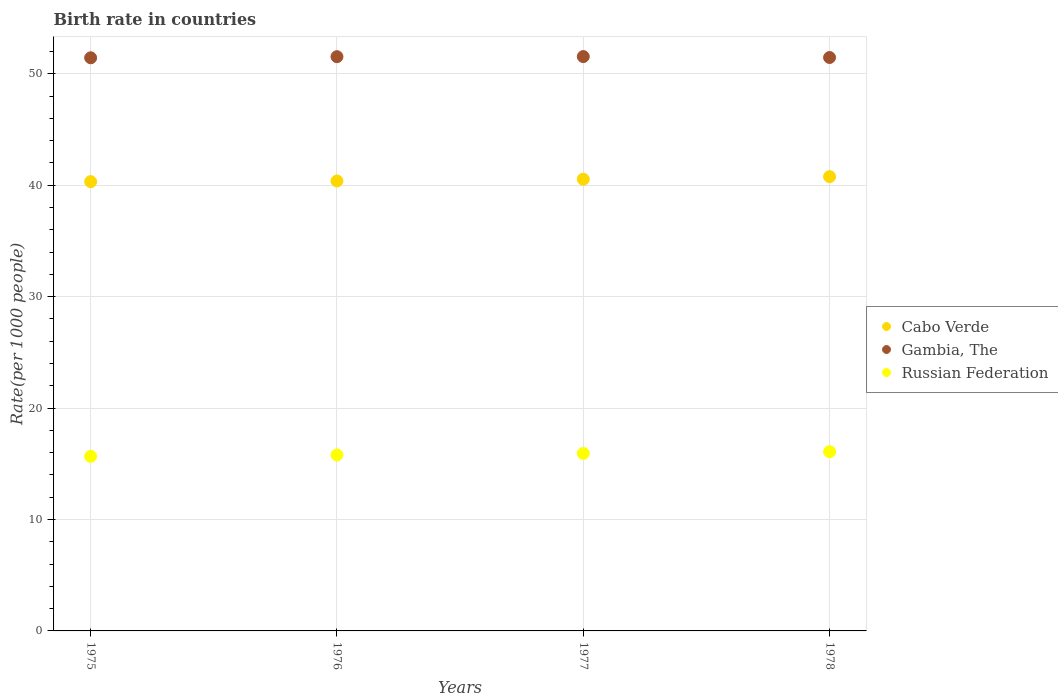How many different coloured dotlines are there?
Offer a terse response. 3. Is the number of dotlines equal to the number of legend labels?
Your answer should be very brief. Yes. What is the birth rate in Gambia, The in 1978?
Offer a very short reply. 51.45. Across all years, what is the maximum birth rate in Cabo Verde?
Keep it short and to the point. 40.76. Across all years, what is the minimum birth rate in Russian Federation?
Provide a short and direct response. 15.66. In which year was the birth rate in Cabo Verde minimum?
Offer a terse response. 1975. What is the total birth rate in Gambia, The in the graph?
Provide a short and direct response. 205.95. What is the difference between the birth rate in Cabo Verde in 1975 and that in 1976?
Provide a succinct answer. -0.06. What is the difference between the birth rate in Gambia, The in 1978 and the birth rate in Cabo Verde in 1977?
Offer a very short reply. 10.92. What is the average birth rate in Gambia, The per year?
Your answer should be very brief. 51.49. In the year 1977, what is the difference between the birth rate in Cabo Verde and birth rate in Gambia, The?
Provide a succinct answer. -11.01. What is the ratio of the birth rate in Gambia, The in 1975 to that in 1978?
Keep it short and to the point. 1. What is the difference between the highest and the second highest birth rate in Cabo Verde?
Offer a very short reply. 0.23. What is the difference between the highest and the lowest birth rate in Gambia, The?
Your response must be concise. 0.11. Is the sum of the birth rate in Gambia, The in 1975 and 1978 greater than the maximum birth rate in Cabo Verde across all years?
Make the answer very short. Yes. Is it the case that in every year, the sum of the birth rate in Russian Federation and birth rate in Cabo Verde  is greater than the birth rate in Gambia, The?
Make the answer very short. Yes. Does the birth rate in Gambia, The monotonically increase over the years?
Make the answer very short. No. How many years are there in the graph?
Your answer should be compact. 4. What is the difference between two consecutive major ticks on the Y-axis?
Your answer should be compact. 10. Are the values on the major ticks of Y-axis written in scientific E-notation?
Ensure brevity in your answer.  No. Does the graph contain any zero values?
Your response must be concise. No. How are the legend labels stacked?
Give a very brief answer. Vertical. What is the title of the graph?
Provide a short and direct response. Birth rate in countries. What is the label or title of the X-axis?
Your answer should be compact. Years. What is the label or title of the Y-axis?
Offer a terse response. Rate(per 1000 people). What is the Rate(per 1000 people) in Cabo Verde in 1975?
Provide a short and direct response. 40.32. What is the Rate(per 1000 people) in Gambia, The in 1975?
Your answer should be compact. 51.43. What is the Rate(per 1000 people) in Russian Federation in 1975?
Your answer should be compact. 15.66. What is the Rate(per 1000 people) of Cabo Verde in 1976?
Your response must be concise. 40.38. What is the Rate(per 1000 people) in Gambia, The in 1976?
Your response must be concise. 51.53. What is the Rate(per 1000 people) of Russian Federation in 1976?
Make the answer very short. 15.79. What is the Rate(per 1000 people) in Cabo Verde in 1977?
Keep it short and to the point. 40.53. What is the Rate(per 1000 people) in Gambia, The in 1977?
Your answer should be very brief. 51.54. What is the Rate(per 1000 people) in Russian Federation in 1977?
Your answer should be compact. 15.92. What is the Rate(per 1000 people) of Cabo Verde in 1978?
Offer a very short reply. 40.76. What is the Rate(per 1000 people) of Gambia, The in 1978?
Offer a terse response. 51.45. What is the Rate(per 1000 people) of Russian Federation in 1978?
Give a very brief answer. 16.08. Across all years, what is the maximum Rate(per 1000 people) of Cabo Verde?
Make the answer very short. 40.76. Across all years, what is the maximum Rate(per 1000 people) of Gambia, The?
Keep it short and to the point. 51.54. Across all years, what is the maximum Rate(per 1000 people) in Russian Federation?
Keep it short and to the point. 16.08. Across all years, what is the minimum Rate(per 1000 people) in Cabo Verde?
Offer a terse response. 40.32. Across all years, what is the minimum Rate(per 1000 people) of Gambia, The?
Offer a terse response. 51.43. Across all years, what is the minimum Rate(per 1000 people) of Russian Federation?
Give a very brief answer. 15.66. What is the total Rate(per 1000 people) of Cabo Verde in the graph?
Ensure brevity in your answer.  161.99. What is the total Rate(per 1000 people) of Gambia, The in the graph?
Ensure brevity in your answer.  205.95. What is the total Rate(per 1000 people) of Russian Federation in the graph?
Provide a short and direct response. 63.45. What is the difference between the Rate(per 1000 people) in Cabo Verde in 1975 and that in 1976?
Ensure brevity in your answer.  -0.06. What is the difference between the Rate(per 1000 people) in Russian Federation in 1975 and that in 1976?
Provide a succinct answer. -0.13. What is the difference between the Rate(per 1000 people) in Cabo Verde in 1975 and that in 1977?
Make the answer very short. -0.22. What is the difference between the Rate(per 1000 people) in Gambia, The in 1975 and that in 1977?
Offer a very short reply. -0.11. What is the difference between the Rate(per 1000 people) of Russian Federation in 1975 and that in 1977?
Offer a terse response. -0.26. What is the difference between the Rate(per 1000 people) in Cabo Verde in 1975 and that in 1978?
Your answer should be compact. -0.45. What is the difference between the Rate(per 1000 people) in Gambia, The in 1975 and that in 1978?
Provide a succinct answer. -0.03. What is the difference between the Rate(per 1000 people) of Russian Federation in 1975 and that in 1978?
Make the answer very short. -0.42. What is the difference between the Rate(per 1000 people) of Cabo Verde in 1976 and that in 1977?
Give a very brief answer. -0.16. What is the difference between the Rate(per 1000 people) of Gambia, The in 1976 and that in 1977?
Provide a short and direct response. -0.01. What is the difference between the Rate(per 1000 people) in Russian Federation in 1976 and that in 1977?
Keep it short and to the point. -0.13. What is the difference between the Rate(per 1000 people) in Cabo Verde in 1976 and that in 1978?
Your response must be concise. -0.39. What is the difference between the Rate(per 1000 people) of Gambia, The in 1976 and that in 1978?
Give a very brief answer. 0.07. What is the difference between the Rate(per 1000 people) in Russian Federation in 1976 and that in 1978?
Your response must be concise. -0.29. What is the difference between the Rate(per 1000 people) in Cabo Verde in 1977 and that in 1978?
Ensure brevity in your answer.  -0.23. What is the difference between the Rate(per 1000 people) in Gambia, The in 1977 and that in 1978?
Keep it short and to the point. 0.08. What is the difference between the Rate(per 1000 people) of Russian Federation in 1977 and that in 1978?
Your response must be concise. -0.16. What is the difference between the Rate(per 1000 people) in Cabo Verde in 1975 and the Rate(per 1000 people) in Gambia, The in 1976?
Your response must be concise. -11.21. What is the difference between the Rate(per 1000 people) in Cabo Verde in 1975 and the Rate(per 1000 people) in Russian Federation in 1976?
Your response must be concise. 24.53. What is the difference between the Rate(per 1000 people) in Gambia, The in 1975 and the Rate(per 1000 people) in Russian Federation in 1976?
Your answer should be very brief. 35.64. What is the difference between the Rate(per 1000 people) in Cabo Verde in 1975 and the Rate(per 1000 people) in Gambia, The in 1977?
Your answer should be very brief. -11.22. What is the difference between the Rate(per 1000 people) of Cabo Verde in 1975 and the Rate(per 1000 people) of Russian Federation in 1977?
Provide a short and direct response. 24.39. What is the difference between the Rate(per 1000 people) of Gambia, The in 1975 and the Rate(per 1000 people) of Russian Federation in 1977?
Your answer should be compact. 35.51. What is the difference between the Rate(per 1000 people) in Cabo Verde in 1975 and the Rate(per 1000 people) in Gambia, The in 1978?
Provide a succinct answer. -11.14. What is the difference between the Rate(per 1000 people) of Cabo Verde in 1975 and the Rate(per 1000 people) of Russian Federation in 1978?
Your answer should be compact. 24.24. What is the difference between the Rate(per 1000 people) of Gambia, The in 1975 and the Rate(per 1000 people) of Russian Federation in 1978?
Make the answer very short. 35.35. What is the difference between the Rate(per 1000 people) in Cabo Verde in 1976 and the Rate(per 1000 people) in Gambia, The in 1977?
Give a very brief answer. -11.16. What is the difference between the Rate(per 1000 people) in Cabo Verde in 1976 and the Rate(per 1000 people) in Russian Federation in 1977?
Give a very brief answer. 24.45. What is the difference between the Rate(per 1000 people) of Gambia, The in 1976 and the Rate(per 1000 people) of Russian Federation in 1977?
Give a very brief answer. 35.61. What is the difference between the Rate(per 1000 people) in Cabo Verde in 1976 and the Rate(per 1000 people) in Gambia, The in 1978?
Provide a short and direct response. -11.08. What is the difference between the Rate(per 1000 people) in Cabo Verde in 1976 and the Rate(per 1000 people) in Russian Federation in 1978?
Your answer should be compact. 24.3. What is the difference between the Rate(per 1000 people) in Gambia, The in 1976 and the Rate(per 1000 people) in Russian Federation in 1978?
Give a very brief answer. 35.45. What is the difference between the Rate(per 1000 people) of Cabo Verde in 1977 and the Rate(per 1000 people) of Gambia, The in 1978?
Give a very brief answer. -10.92. What is the difference between the Rate(per 1000 people) in Cabo Verde in 1977 and the Rate(per 1000 people) in Russian Federation in 1978?
Ensure brevity in your answer.  24.45. What is the difference between the Rate(per 1000 people) of Gambia, The in 1977 and the Rate(per 1000 people) of Russian Federation in 1978?
Your answer should be very brief. 35.46. What is the average Rate(per 1000 people) in Cabo Verde per year?
Your answer should be compact. 40.5. What is the average Rate(per 1000 people) of Gambia, The per year?
Offer a very short reply. 51.49. What is the average Rate(per 1000 people) of Russian Federation per year?
Your answer should be very brief. 15.86. In the year 1975, what is the difference between the Rate(per 1000 people) of Cabo Verde and Rate(per 1000 people) of Gambia, The?
Provide a short and direct response. -11.11. In the year 1975, what is the difference between the Rate(per 1000 people) in Cabo Verde and Rate(per 1000 people) in Russian Federation?
Provide a short and direct response. 24.65. In the year 1975, what is the difference between the Rate(per 1000 people) in Gambia, The and Rate(per 1000 people) in Russian Federation?
Your answer should be very brief. 35.77. In the year 1976, what is the difference between the Rate(per 1000 people) of Cabo Verde and Rate(per 1000 people) of Gambia, The?
Ensure brevity in your answer.  -11.15. In the year 1976, what is the difference between the Rate(per 1000 people) of Cabo Verde and Rate(per 1000 people) of Russian Federation?
Provide a short and direct response. 24.59. In the year 1976, what is the difference between the Rate(per 1000 people) of Gambia, The and Rate(per 1000 people) of Russian Federation?
Offer a very short reply. 35.74. In the year 1977, what is the difference between the Rate(per 1000 people) in Cabo Verde and Rate(per 1000 people) in Gambia, The?
Your answer should be very brief. -11.01. In the year 1977, what is the difference between the Rate(per 1000 people) of Cabo Verde and Rate(per 1000 people) of Russian Federation?
Your answer should be compact. 24.61. In the year 1977, what is the difference between the Rate(per 1000 people) in Gambia, The and Rate(per 1000 people) in Russian Federation?
Your answer should be very brief. 35.62. In the year 1978, what is the difference between the Rate(per 1000 people) of Cabo Verde and Rate(per 1000 people) of Gambia, The?
Offer a very short reply. -10.69. In the year 1978, what is the difference between the Rate(per 1000 people) of Cabo Verde and Rate(per 1000 people) of Russian Federation?
Your answer should be very brief. 24.68. In the year 1978, what is the difference between the Rate(per 1000 people) of Gambia, The and Rate(per 1000 people) of Russian Federation?
Make the answer very short. 35.38. What is the ratio of the Rate(per 1000 people) in Gambia, The in 1975 to that in 1976?
Your answer should be very brief. 1. What is the ratio of the Rate(per 1000 people) of Russian Federation in 1975 to that in 1976?
Make the answer very short. 0.99. What is the ratio of the Rate(per 1000 people) of Cabo Verde in 1975 to that in 1977?
Give a very brief answer. 0.99. What is the ratio of the Rate(per 1000 people) in Gambia, The in 1975 to that in 1977?
Ensure brevity in your answer.  1. What is the ratio of the Rate(per 1000 people) of Russian Federation in 1975 to that in 1977?
Provide a succinct answer. 0.98. What is the ratio of the Rate(per 1000 people) of Gambia, The in 1975 to that in 1978?
Your answer should be very brief. 1. What is the ratio of the Rate(per 1000 people) in Russian Federation in 1975 to that in 1978?
Provide a short and direct response. 0.97. What is the ratio of the Rate(per 1000 people) in Russian Federation in 1976 to that in 1977?
Offer a very short reply. 0.99. What is the ratio of the Rate(per 1000 people) of Cabo Verde in 1976 to that in 1978?
Your response must be concise. 0.99. What is the ratio of the Rate(per 1000 people) in Gambia, The in 1976 to that in 1978?
Ensure brevity in your answer.  1. What is the ratio of the Rate(per 1000 people) of Russian Federation in 1976 to that in 1978?
Keep it short and to the point. 0.98. What is the ratio of the Rate(per 1000 people) of Cabo Verde in 1977 to that in 1978?
Make the answer very short. 0.99. What is the ratio of the Rate(per 1000 people) of Russian Federation in 1977 to that in 1978?
Offer a terse response. 0.99. What is the difference between the highest and the second highest Rate(per 1000 people) in Cabo Verde?
Offer a very short reply. 0.23. What is the difference between the highest and the second highest Rate(per 1000 people) of Russian Federation?
Keep it short and to the point. 0.16. What is the difference between the highest and the lowest Rate(per 1000 people) of Cabo Verde?
Make the answer very short. 0.45. What is the difference between the highest and the lowest Rate(per 1000 people) in Gambia, The?
Your answer should be compact. 0.11. What is the difference between the highest and the lowest Rate(per 1000 people) of Russian Federation?
Provide a short and direct response. 0.42. 